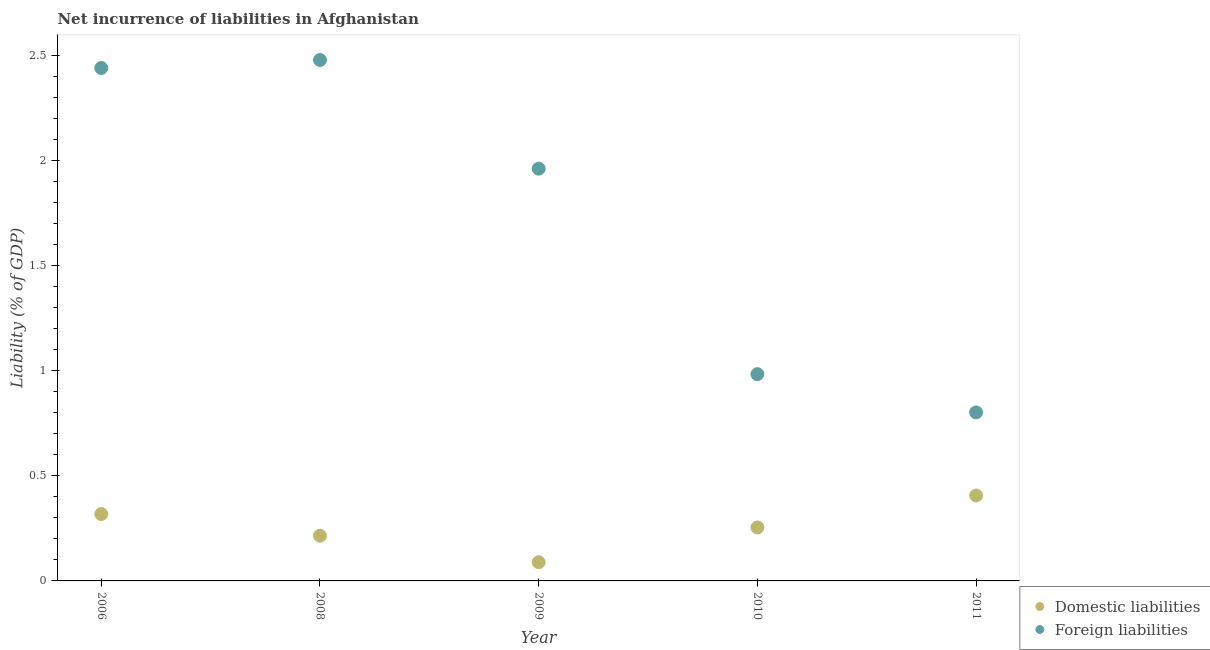How many different coloured dotlines are there?
Offer a very short reply. 2. What is the incurrence of domestic liabilities in 2008?
Make the answer very short. 0.22. Across all years, what is the maximum incurrence of domestic liabilities?
Offer a very short reply. 0.41. Across all years, what is the minimum incurrence of domestic liabilities?
Your answer should be very brief. 0.09. In which year was the incurrence of domestic liabilities minimum?
Provide a short and direct response. 2009. What is the total incurrence of domestic liabilities in the graph?
Your answer should be compact. 1.28. What is the difference between the incurrence of domestic liabilities in 2006 and that in 2011?
Make the answer very short. -0.09. What is the difference between the incurrence of foreign liabilities in 2011 and the incurrence of domestic liabilities in 2006?
Keep it short and to the point. 0.48. What is the average incurrence of foreign liabilities per year?
Give a very brief answer. 1.73. In the year 2008, what is the difference between the incurrence of foreign liabilities and incurrence of domestic liabilities?
Make the answer very short. 2.26. In how many years, is the incurrence of domestic liabilities greater than 2.3 %?
Ensure brevity in your answer.  0. What is the ratio of the incurrence of domestic liabilities in 2009 to that in 2010?
Offer a terse response. 0.35. Is the incurrence of domestic liabilities in 2008 less than that in 2009?
Provide a succinct answer. No. Is the difference between the incurrence of foreign liabilities in 2006 and 2009 greater than the difference between the incurrence of domestic liabilities in 2006 and 2009?
Keep it short and to the point. Yes. What is the difference between the highest and the second highest incurrence of domestic liabilities?
Your answer should be compact. 0.09. What is the difference between the highest and the lowest incurrence of foreign liabilities?
Your response must be concise. 1.68. In how many years, is the incurrence of domestic liabilities greater than the average incurrence of domestic liabilities taken over all years?
Your answer should be compact. 2. Is the sum of the incurrence of domestic liabilities in 2009 and 2010 greater than the maximum incurrence of foreign liabilities across all years?
Keep it short and to the point. No. What is the difference between two consecutive major ticks on the Y-axis?
Your answer should be compact. 0.5. Does the graph contain grids?
Your answer should be compact. No. Where does the legend appear in the graph?
Offer a very short reply. Bottom right. How many legend labels are there?
Give a very brief answer. 2. What is the title of the graph?
Your response must be concise. Net incurrence of liabilities in Afghanistan. Does "Savings" appear as one of the legend labels in the graph?
Ensure brevity in your answer.  No. What is the label or title of the X-axis?
Your answer should be very brief. Year. What is the label or title of the Y-axis?
Keep it short and to the point. Liability (% of GDP). What is the Liability (% of GDP) in Domestic liabilities in 2006?
Your response must be concise. 0.32. What is the Liability (% of GDP) in Foreign liabilities in 2006?
Your answer should be compact. 2.44. What is the Liability (% of GDP) of Domestic liabilities in 2008?
Ensure brevity in your answer.  0.22. What is the Liability (% of GDP) of Foreign liabilities in 2008?
Ensure brevity in your answer.  2.48. What is the Liability (% of GDP) in Domestic liabilities in 2009?
Keep it short and to the point. 0.09. What is the Liability (% of GDP) in Foreign liabilities in 2009?
Provide a succinct answer. 1.96. What is the Liability (% of GDP) in Domestic liabilities in 2010?
Provide a succinct answer. 0.25. What is the Liability (% of GDP) of Foreign liabilities in 2010?
Provide a short and direct response. 0.98. What is the Liability (% of GDP) of Domestic liabilities in 2011?
Your response must be concise. 0.41. What is the Liability (% of GDP) of Foreign liabilities in 2011?
Make the answer very short. 0.8. Across all years, what is the maximum Liability (% of GDP) of Domestic liabilities?
Provide a succinct answer. 0.41. Across all years, what is the maximum Liability (% of GDP) in Foreign liabilities?
Provide a short and direct response. 2.48. Across all years, what is the minimum Liability (% of GDP) of Domestic liabilities?
Provide a short and direct response. 0.09. Across all years, what is the minimum Liability (% of GDP) in Foreign liabilities?
Provide a succinct answer. 0.8. What is the total Liability (% of GDP) in Domestic liabilities in the graph?
Ensure brevity in your answer.  1.28. What is the total Liability (% of GDP) of Foreign liabilities in the graph?
Your answer should be compact. 8.67. What is the difference between the Liability (% of GDP) in Domestic liabilities in 2006 and that in 2008?
Offer a very short reply. 0.1. What is the difference between the Liability (% of GDP) in Foreign liabilities in 2006 and that in 2008?
Provide a succinct answer. -0.04. What is the difference between the Liability (% of GDP) in Domestic liabilities in 2006 and that in 2009?
Your answer should be compact. 0.23. What is the difference between the Liability (% of GDP) in Foreign liabilities in 2006 and that in 2009?
Provide a short and direct response. 0.48. What is the difference between the Liability (% of GDP) of Domestic liabilities in 2006 and that in 2010?
Make the answer very short. 0.06. What is the difference between the Liability (% of GDP) of Foreign liabilities in 2006 and that in 2010?
Keep it short and to the point. 1.46. What is the difference between the Liability (% of GDP) in Domestic liabilities in 2006 and that in 2011?
Your response must be concise. -0.09. What is the difference between the Liability (% of GDP) of Foreign liabilities in 2006 and that in 2011?
Your answer should be compact. 1.64. What is the difference between the Liability (% of GDP) of Domestic liabilities in 2008 and that in 2009?
Make the answer very short. 0.13. What is the difference between the Liability (% of GDP) of Foreign liabilities in 2008 and that in 2009?
Offer a terse response. 0.52. What is the difference between the Liability (% of GDP) in Domestic liabilities in 2008 and that in 2010?
Keep it short and to the point. -0.04. What is the difference between the Liability (% of GDP) in Foreign liabilities in 2008 and that in 2010?
Your answer should be compact. 1.5. What is the difference between the Liability (% of GDP) of Domestic liabilities in 2008 and that in 2011?
Offer a terse response. -0.19. What is the difference between the Liability (% of GDP) in Foreign liabilities in 2008 and that in 2011?
Your response must be concise. 1.68. What is the difference between the Liability (% of GDP) in Domestic liabilities in 2009 and that in 2010?
Offer a very short reply. -0.17. What is the difference between the Liability (% of GDP) in Foreign liabilities in 2009 and that in 2010?
Ensure brevity in your answer.  0.98. What is the difference between the Liability (% of GDP) of Domestic liabilities in 2009 and that in 2011?
Ensure brevity in your answer.  -0.32. What is the difference between the Liability (% of GDP) in Foreign liabilities in 2009 and that in 2011?
Make the answer very short. 1.16. What is the difference between the Liability (% of GDP) of Domestic liabilities in 2010 and that in 2011?
Ensure brevity in your answer.  -0.15. What is the difference between the Liability (% of GDP) of Foreign liabilities in 2010 and that in 2011?
Offer a very short reply. 0.18. What is the difference between the Liability (% of GDP) of Domestic liabilities in 2006 and the Liability (% of GDP) of Foreign liabilities in 2008?
Ensure brevity in your answer.  -2.16. What is the difference between the Liability (% of GDP) of Domestic liabilities in 2006 and the Liability (% of GDP) of Foreign liabilities in 2009?
Your response must be concise. -1.64. What is the difference between the Liability (% of GDP) in Domestic liabilities in 2006 and the Liability (% of GDP) in Foreign liabilities in 2010?
Keep it short and to the point. -0.67. What is the difference between the Liability (% of GDP) in Domestic liabilities in 2006 and the Liability (% of GDP) in Foreign liabilities in 2011?
Ensure brevity in your answer.  -0.48. What is the difference between the Liability (% of GDP) in Domestic liabilities in 2008 and the Liability (% of GDP) in Foreign liabilities in 2009?
Provide a succinct answer. -1.75. What is the difference between the Liability (% of GDP) of Domestic liabilities in 2008 and the Liability (% of GDP) of Foreign liabilities in 2010?
Provide a succinct answer. -0.77. What is the difference between the Liability (% of GDP) of Domestic liabilities in 2008 and the Liability (% of GDP) of Foreign liabilities in 2011?
Make the answer very short. -0.59. What is the difference between the Liability (% of GDP) in Domestic liabilities in 2009 and the Liability (% of GDP) in Foreign liabilities in 2010?
Your response must be concise. -0.9. What is the difference between the Liability (% of GDP) in Domestic liabilities in 2009 and the Liability (% of GDP) in Foreign liabilities in 2011?
Keep it short and to the point. -0.71. What is the difference between the Liability (% of GDP) in Domestic liabilities in 2010 and the Liability (% of GDP) in Foreign liabilities in 2011?
Offer a terse response. -0.55. What is the average Liability (% of GDP) of Domestic liabilities per year?
Your answer should be compact. 0.26. What is the average Liability (% of GDP) in Foreign liabilities per year?
Offer a terse response. 1.73. In the year 2006, what is the difference between the Liability (% of GDP) of Domestic liabilities and Liability (% of GDP) of Foreign liabilities?
Offer a terse response. -2.12. In the year 2008, what is the difference between the Liability (% of GDP) of Domestic liabilities and Liability (% of GDP) of Foreign liabilities?
Provide a short and direct response. -2.26. In the year 2009, what is the difference between the Liability (% of GDP) in Domestic liabilities and Liability (% of GDP) in Foreign liabilities?
Provide a succinct answer. -1.87. In the year 2010, what is the difference between the Liability (% of GDP) of Domestic liabilities and Liability (% of GDP) of Foreign liabilities?
Provide a succinct answer. -0.73. In the year 2011, what is the difference between the Liability (% of GDP) of Domestic liabilities and Liability (% of GDP) of Foreign liabilities?
Your answer should be compact. -0.4. What is the ratio of the Liability (% of GDP) of Domestic liabilities in 2006 to that in 2008?
Your answer should be compact. 1.48. What is the ratio of the Liability (% of GDP) of Foreign liabilities in 2006 to that in 2008?
Make the answer very short. 0.98. What is the ratio of the Liability (% of GDP) in Domestic liabilities in 2006 to that in 2009?
Provide a short and direct response. 3.57. What is the ratio of the Liability (% of GDP) in Foreign liabilities in 2006 to that in 2009?
Keep it short and to the point. 1.24. What is the ratio of the Liability (% of GDP) of Domestic liabilities in 2006 to that in 2010?
Your answer should be compact. 1.25. What is the ratio of the Liability (% of GDP) in Foreign liabilities in 2006 to that in 2010?
Provide a short and direct response. 2.48. What is the ratio of the Liability (% of GDP) in Domestic liabilities in 2006 to that in 2011?
Your answer should be compact. 0.78. What is the ratio of the Liability (% of GDP) in Foreign liabilities in 2006 to that in 2011?
Offer a terse response. 3.04. What is the ratio of the Liability (% of GDP) in Domestic liabilities in 2008 to that in 2009?
Provide a succinct answer. 2.41. What is the ratio of the Liability (% of GDP) in Foreign liabilities in 2008 to that in 2009?
Provide a succinct answer. 1.26. What is the ratio of the Liability (% of GDP) of Domestic liabilities in 2008 to that in 2010?
Offer a very short reply. 0.84. What is the ratio of the Liability (% of GDP) of Foreign liabilities in 2008 to that in 2010?
Give a very brief answer. 2.52. What is the ratio of the Liability (% of GDP) in Domestic liabilities in 2008 to that in 2011?
Ensure brevity in your answer.  0.53. What is the ratio of the Liability (% of GDP) of Foreign liabilities in 2008 to that in 2011?
Offer a terse response. 3.09. What is the ratio of the Liability (% of GDP) of Domestic liabilities in 2009 to that in 2010?
Make the answer very short. 0.35. What is the ratio of the Liability (% of GDP) in Foreign liabilities in 2009 to that in 2010?
Make the answer very short. 1.99. What is the ratio of the Liability (% of GDP) in Domestic liabilities in 2009 to that in 2011?
Keep it short and to the point. 0.22. What is the ratio of the Liability (% of GDP) of Foreign liabilities in 2009 to that in 2011?
Your response must be concise. 2.45. What is the ratio of the Liability (% of GDP) of Domestic liabilities in 2010 to that in 2011?
Keep it short and to the point. 0.63. What is the ratio of the Liability (% of GDP) in Foreign liabilities in 2010 to that in 2011?
Make the answer very short. 1.23. What is the difference between the highest and the second highest Liability (% of GDP) in Domestic liabilities?
Keep it short and to the point. 0.09. What is the difference between the highest and the second highest Liability (% of GDP) of Foreign liabilities?
Keep it short and to the point. 0.04. What is the difference between the highest and the lowest Liability (% of GDP) in Domestic liabilities?
Your answer should be compact. 0.32. What is the difference between the highest and the lowest Liability (% of GDP) of Foreign liabilities?
Offer a terse response. 1.68. 